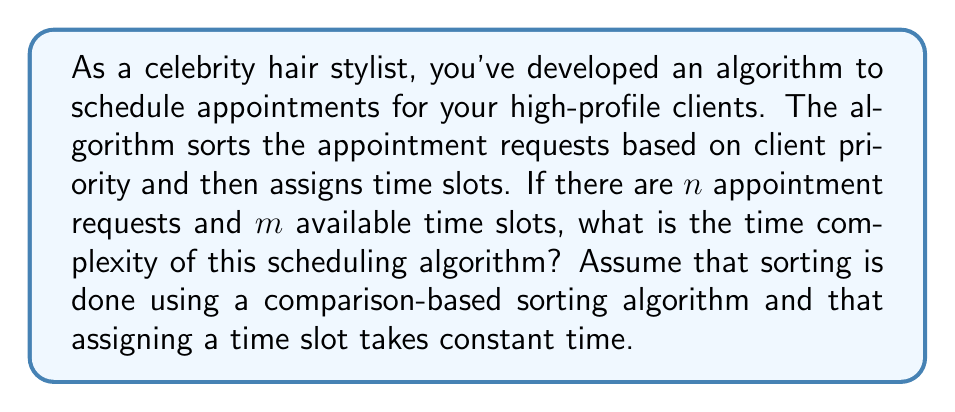Give your solution to this math problem. To analyze the time complexity of this scheduling algorithm, we need to break it down into its component parts:

1. Sorting the appointment requests:
   The algorithm first sorts the appointment requests based on client priority. For $n$ appointment requests, using a comparison-based sorting algorithm (like QuickSort, MergeSort, or HeapSort), the time complexity is $O(n \log n)$.

2. Assigning time slots:
   After sorting, the algorithm assigns time slots to the sorted requests. Since assigning a time slot takes constant time, and we do this for each of the $n$ requests (or until we run out of time slots), this step has a time complexity of $O(n)$.

The overall time complexity is the sum of these two steps:

$$ T(n) = O(n \log n) + O(n) $$

When we have two terms added together in Big O notation, we keep the dominant (slower-growing) term. In this case, $O(n \log n)$ grows faster than $O(n)$ for large values of $n$, so it dominates.

Therefore, the overall time complexity of the scheduling algorithm is $O(n \log n)$.

Note that the number of available time slots $(m)$ doesn't affect the asymptotic time complexity in this case, as we're primarily concerned with processing the $n$ appointment requests.
Answer: $O(n \log n)$ 